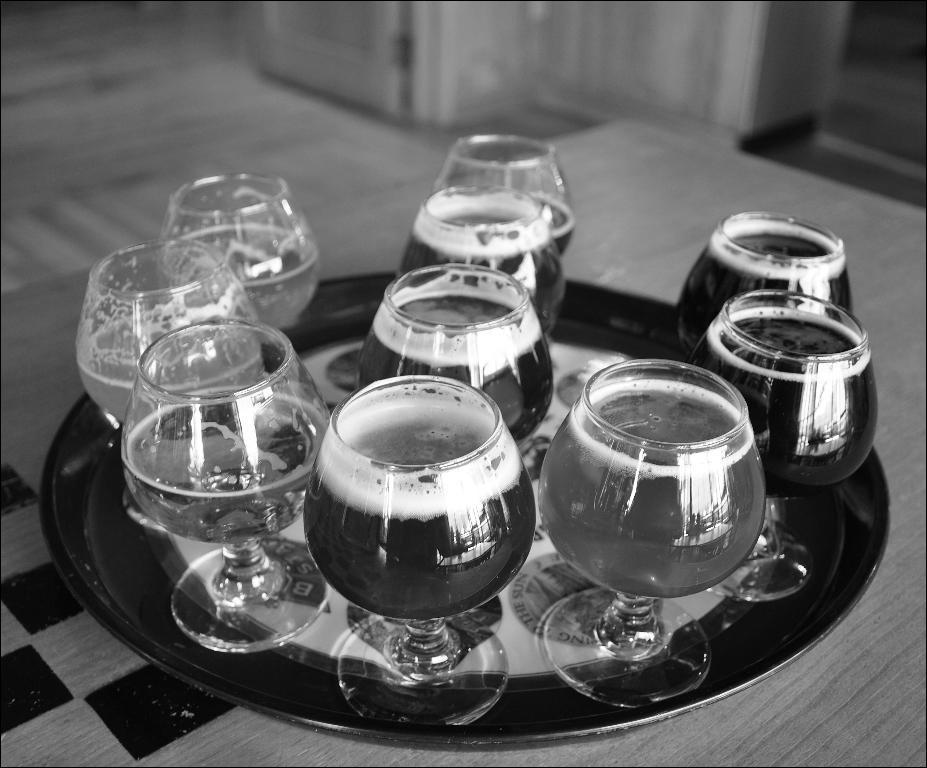Describe this image in one or two sentences. This is a black and white image. In the center of the image we can see beverage in glass tumblers in plate placed on the table. 